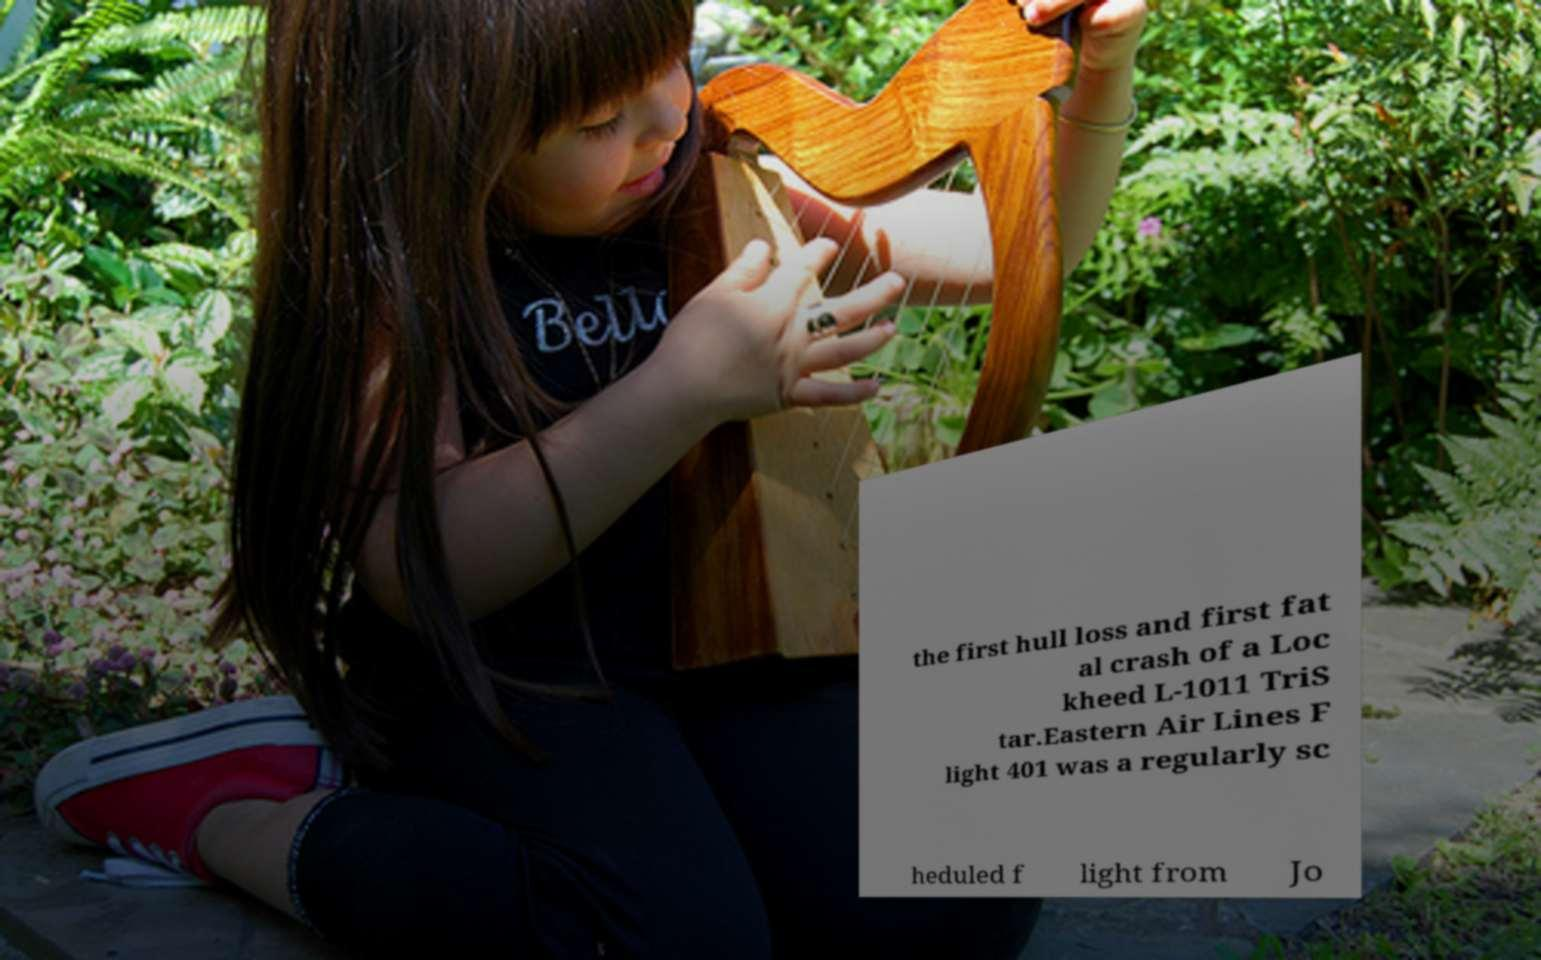For documentation purposes, I need the text within this image transcribed. Could you provide that? the first hull loss and first fat al crash of a Loc kheed L-1011 TriS tar.Eastern Air Lines F light 401 was a regularly sc heduled f light from Jo 